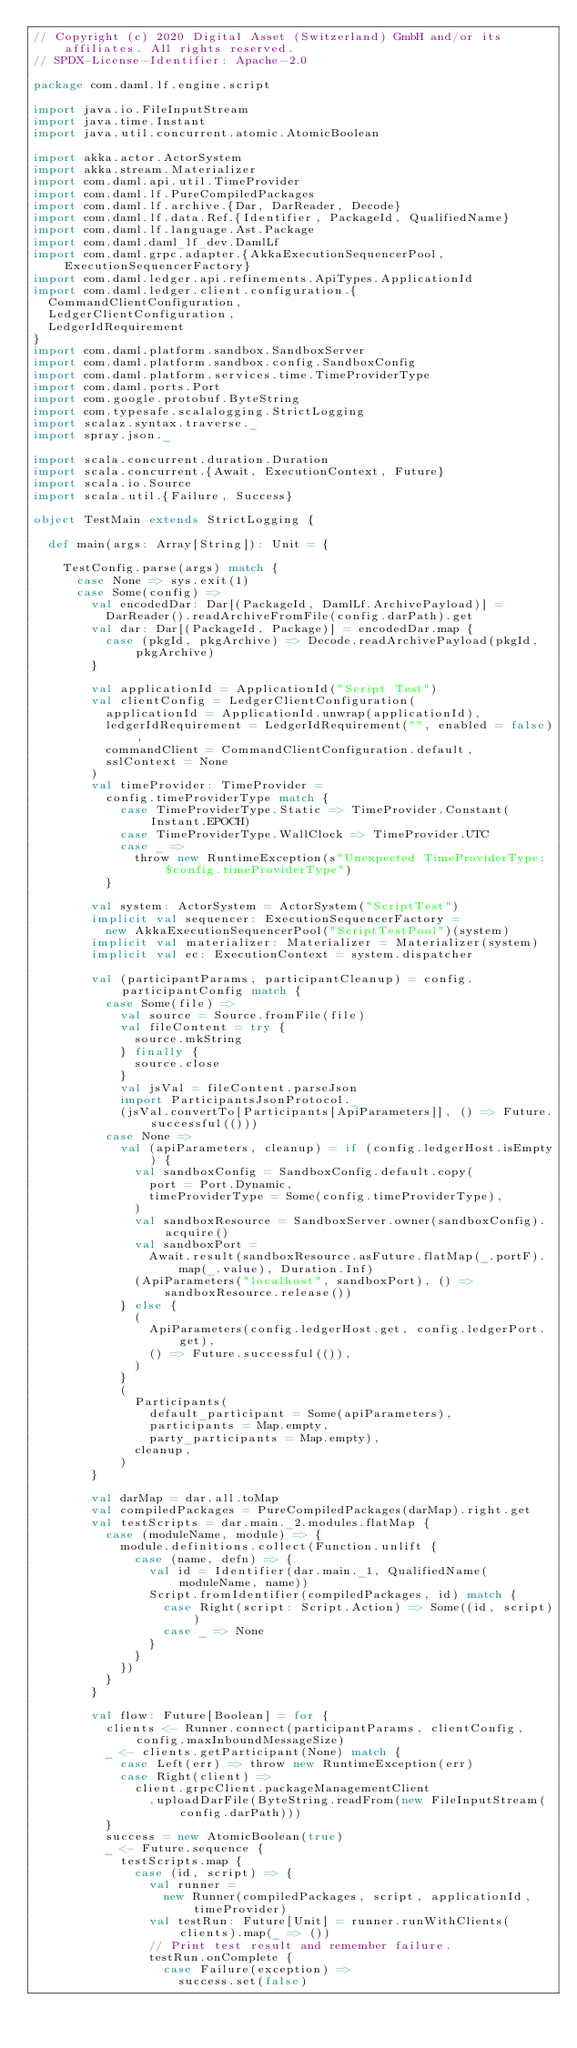<code> <loc_0><loc_0><loc_500><loc_500><_Scala_>// Copyright (c) 2020 Digital Asset (Switzerland) GmbH and/or its affiliates. All rights reserved.
// SPDX-License-Identifier: Apache-2.0

package com.daml.lf.engine.script

import java.io.FileInputStream
import java.time.Instant
import java.util.concurrent.atomic.AtomicBoolean

import akka.actor.ActorSystem
import akka.stream.Materializer
import com.daml.api.util.TimeProvider
import com.daml.lf.PureCompiledPackages
import com.daml.lf.archive.{Dar, DarReader, Decode}
import com.daml.lf.data.Ref.{Identifier, PackageId, QualifiedName}
import com.daml.lf.language.Ast.Package
import com.daml.daml_lf_dev.DamlLf
import com.daml.grpc.adapter.{AkkaExecutionSequencerPool, ExecutionSequencerFactory}
import com.daml.ledger.api.refinements.ApiTypes.ApplicationId
import com.daml.ledger.client.configuration.{
  CommandClientConfiguration,
  LedgerClientConfiguration,
  LedgerIdRequirement
}
import com.daml.platform.sandbox.SandboxServer
import com.daml.platform.sandbox.config.SandboxConfig
import com.daml.platform.services.time.TimeProviderType
import com.daml.ports.Port
import com.google.protobuf.ByteString
import com.typesafe.scalalogging.StrictLogging
import scalaz.syntax.traverse._
import spray.json._

import scala.concurrent.duration.Duration
import scala.concurrent.{Await, ExecutionContext, Future}
import scala.io.Source
import scala.util.{Failure, Success}

object TestMain extends StrictLogging {

  def main(args: Array[String]): Unit = {

    TestConfig.parse(args) match {
      case None => sys.exit(1)
      case Some(config) =>
        val encodedDar: Dar[(PackageId, DamlLf.ArchivePayload)] =
          DarReader().readArchiveFromFile(config.darPath).get
        val dar: Dar[(PackageId, Package)] = encodedDar.map {
          case (pkgId, pkgArchive) => Decode.readArchivePayload(pkgId, pkgArchive)
        }

        val applicationId = ApplicationId("Script Test")
        val clientConfig = LedgerClientConfiguration(
          applicationId = ApplicationId.unwrap(applicationId),
          ledgerIdRequirement = LedgerIdRequirement("", enabled = false),
          commandClient = CommandClientConfiguration.default,
          sslContext = None
        )
        val timeProvider: TimeProvider =
          config.timeProviderType match {
            case TimeProviderType.Static => TimeProvider.Constant(Instant.EPOCH)
            case TimeProviderType.WallClock => TimeProvider.UTC
            case _ =>
              throw new RuntimeException(s"Unexpected TimeProviderType: $config.timeProviderType")
          }

        val system: ActorSystem = ActorSystem("ScriptTest")
        implicit val sequencer: ExecutionSequencerFactory =
          new AkkaExecutionSequencerPool("ScriptTestPool")(system)
        implicit val materializer: Materializer = Materializer(system)
        implicit val ec: ExecutionContext = system.dispatcher

        val (participantParams, participantCleanup) = config.participantConfig match {
          case Some(file) =>
            val source = Source.fromFile(file)
            val fileContent = try {
              source.mkString
            } finally {
              source.close
            }
            val jsVal = fileContent.parseJson
            import ParticipantsJsonProtocol._
            (jsVal.convertTo[Participants[ApiParameters]], () => Future.successful(()))
          case None =>
            val (apiParameters, cleanup) = if (config.ledgerHost.isEmpty) {
              val sandboxConfig = SandboxConfig.default.copy(
                port = Port.Dynamic,
                timeProviderType = Some(config.timeProviderType),
              )
              val sandboxResource = SandboxServer.owner(sandboxConfig).acquire()
              val sandboxPort =
                Await.result(sandboxResource.asFuture.flatMap(_.portF).map(_.value), Duration.Inf)
              (ApiParameters("localhost", sandboxPort), () => sandboxResource.release())
            } else {
              (
                ApiParameters(config.ledgerHost.get, config.ledgerPort.get),
                () => Future.successful(()),
              )
            }
            (
              Participants(
                default_participant = Some(apiParameters),
                participants = Map.empty,
                party_participants = Map.empty),
              cleanup,
            )
        }

        val darMap = dar.all.toMap
        val compiledPackages = PureCompiledPackages(darMap).right.get
        val testScripts = dar.main._2.modules.flatMap {
          case (moduleName, module) => {
            module.definitions.collect(Function.unlift {
              case (name, defn) => {
                val id = Identifier(dar.main._1, QualifiedName(moduleName, name))
                Script.fromIdentifier(compiledPackages, id) match {
                  case Right(script: Script.Action) => Some((id, script))
                  case _ => None
                }
              }
            })
          }
        }

        val flow: Future[Boolean] = for {
          clients <- Runner.connect(participantParams, clientConfig, config.maxInboundMessageSize)
          _ <- clients.getParticipant(None) match {
            case Left(err) => throw new RuntimeException(err)
            case Right(client) =>
              client.grpcClient.packageManagementClient
                .uploadDarFile(ByteString.readFrom(new FileInputStream(config.darPath)))
          }
          success = new AtomicBoolean(true)
          _ <- Future.sequence {
            testScripts.map {
              case (id, script) => {
                val runner =
                  new Runner(compiledPackages, script, applicationId, timeProvider)
                val testRun: Future[Unit] = runner.runWithClients(clients).map(_ => ())
                // Print test result and remember failure.
                testRun.onComplete {
                  case Failure(exception) =>
                    success.set(false)</code> 